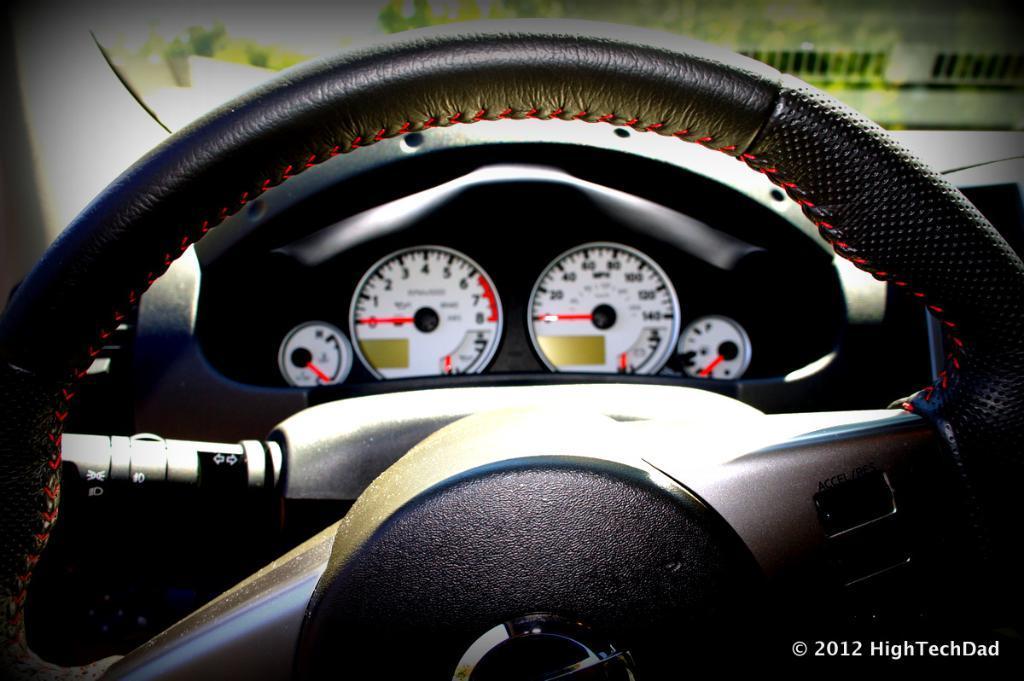Please provide a concise description of this image. In the picture we can see a steering which is black in color under it we can see speed-o-meters and fuel meter and behind the steering we can see a windshield. 